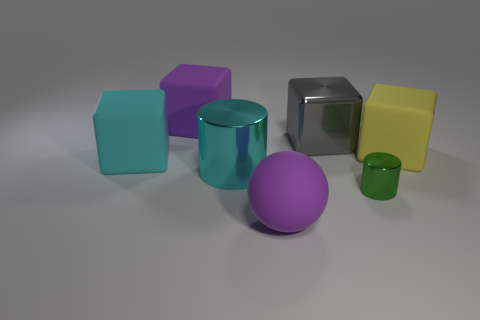What number of big yellow blocks are in front of the tiny green metal cylinder?
Offer a terse response. 0. Are there more yellow cylinders than shiny things?
Give a very brief answer. No. What size is the rubber thing that is the same color as the large matte ball?
Keep it short and to the point. Large. There is a rubber thing that is both behind the cyan cylinder and to the right of the cyan metallic cylinder; what is its size?
Your answer should be very brief. Large. There is a purple thing to the left of the big purple object that is in front of the cyan matte cube behind the purple rubber sphere; what is its material?
Provide a short and direct response. Rubber. There is a big block that is the same color as the large ball; what is its material?
Make the answer very short. Rubber. There is a matte block in front of the yellow thing; is its color the same as the shiny thing behind the big cyan block?
Your response must be concise. No. There is a big purple thing that is on the left side of the cyan thing on the right side of the big block that is in front of the yellow thing; what is its shape?
Offer a terse response. Cube. There is a thing that is both to the right of the matte ball and in front of the big cyan shiny thing; what shape is it?
Make the answer very short. Cylinder. How many cyan things are on the right side of the matte object that is to the left of the purple rubber thing on the left side of the cyan cylinder?
Your answer should be compact. 1. 